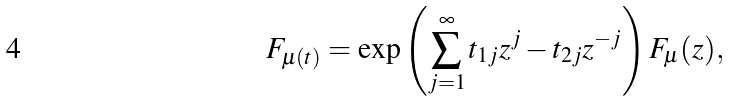Convert formula to latex. <formula><loc_0><loc_0><loc_500><loc_500>F _ { \mu ( t ) } = \exp \left ( \sum _ { j = 1 } ^ { \infty } t _ { 1 j } z ^ { j } - t _ { 2 j } z ^ { - j } \right ) F _ { \mu } ( z ) ,</formula> 